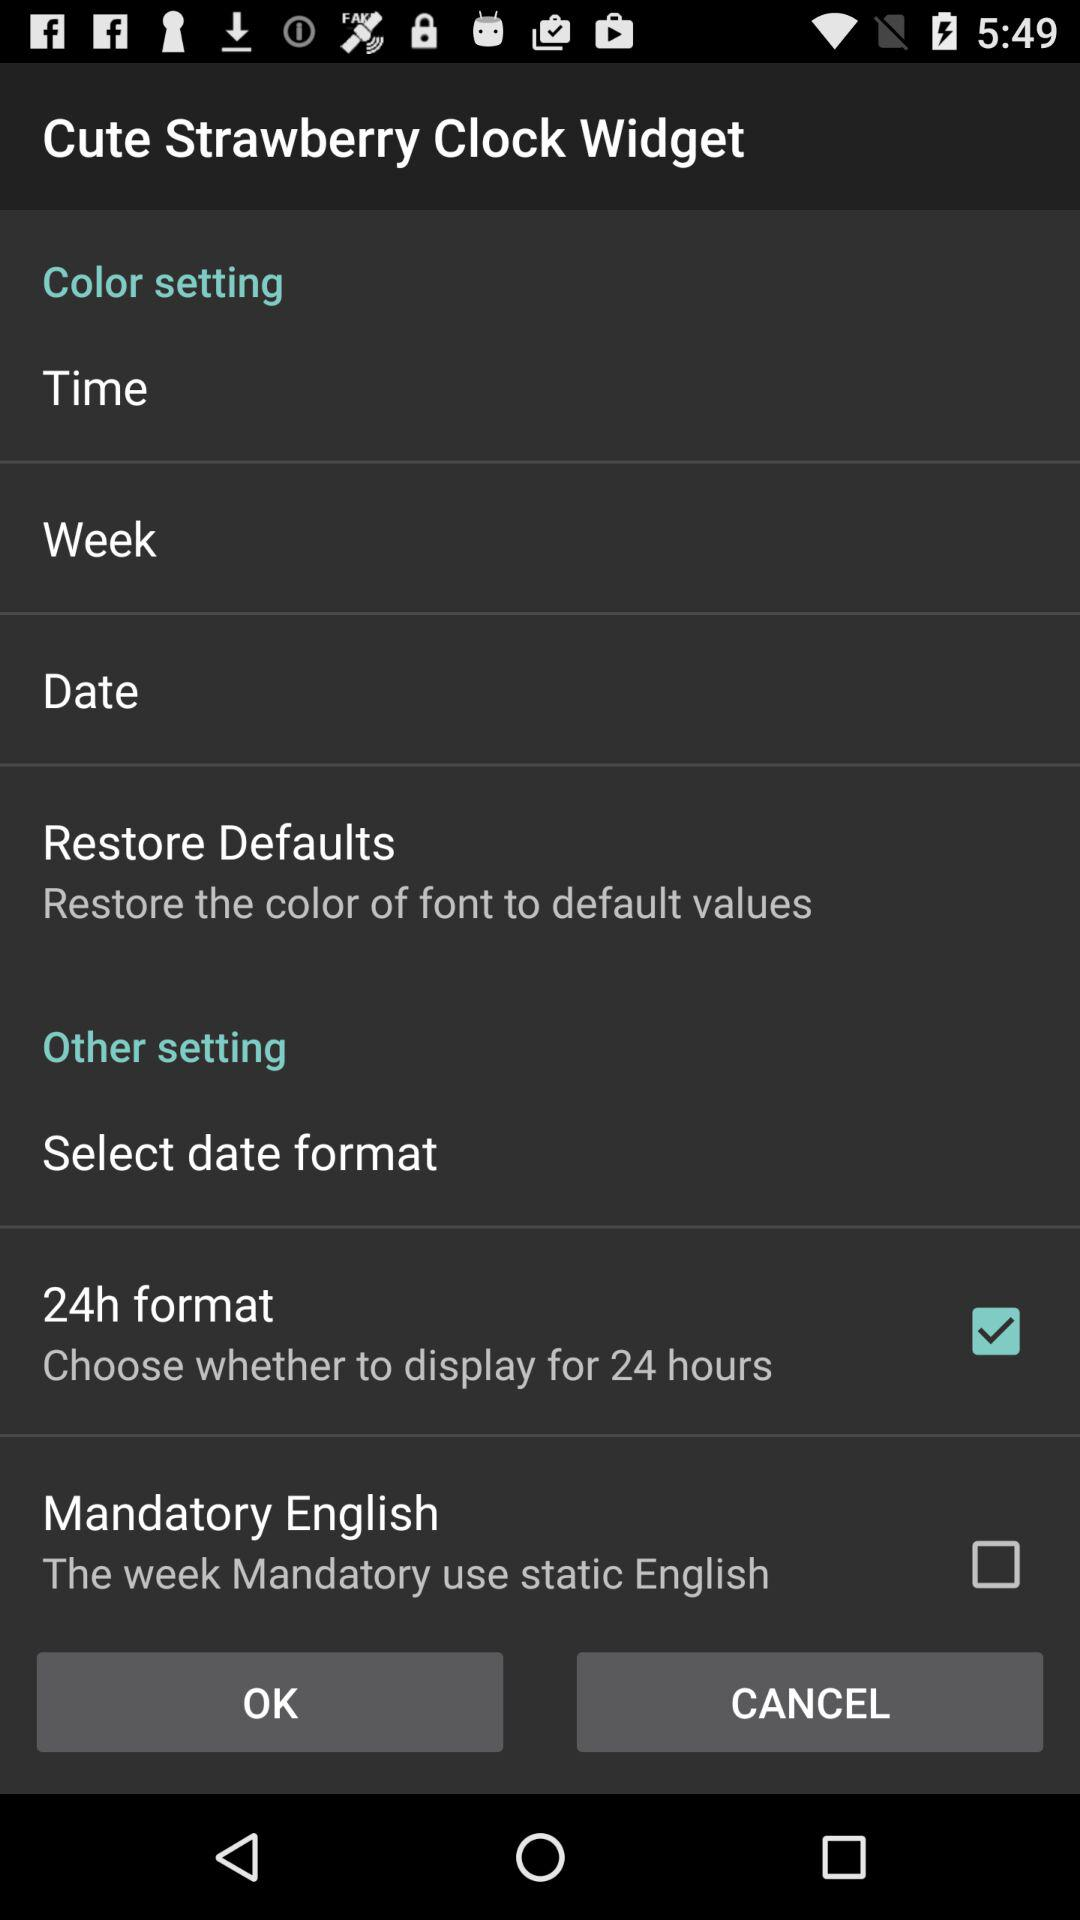What date format has been selected? The date format that has been selected is the 24 hour format. 